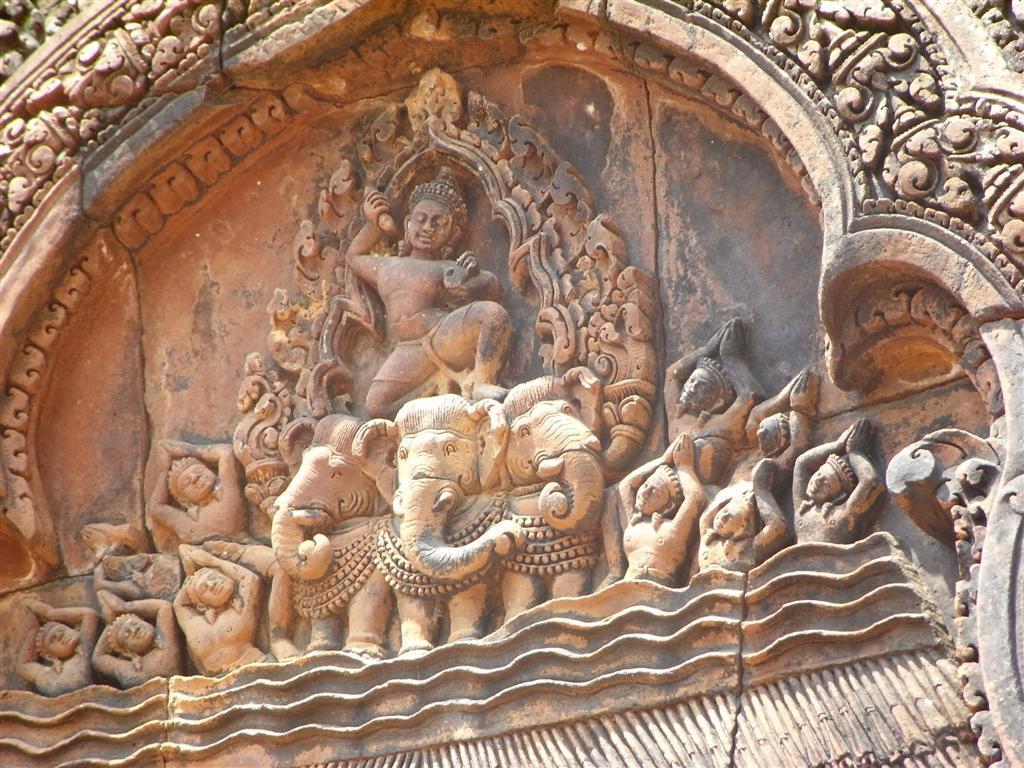How would you summarize this image in a sentence or two? In this image we can see the sculpture of animals and persons on the stone wall. 